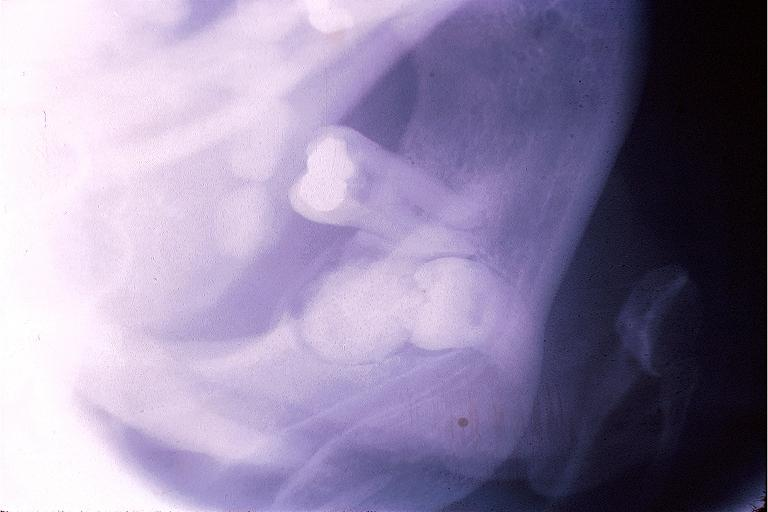what does this image show?
Answer the question using a single word or phrase. Complex odontoma 